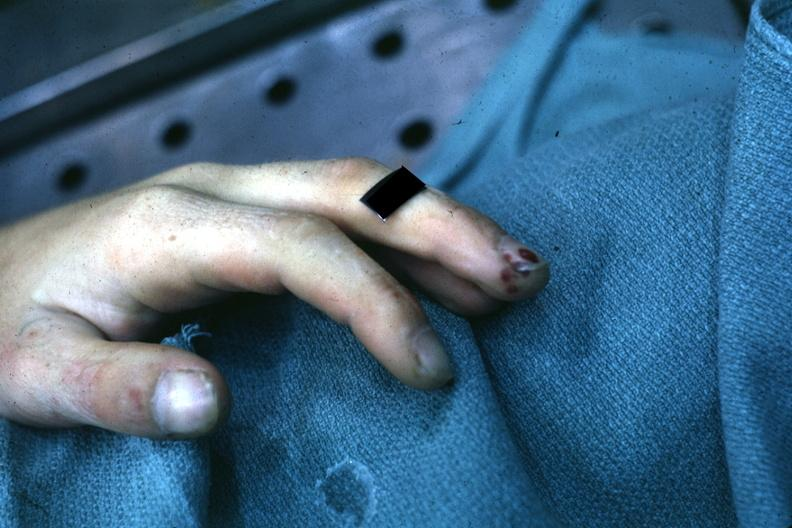what is very good example of focal necrotizing lesions in distal portion of digit associated?
Answer the question using a single word or phrase. With bacterial endocarditis 